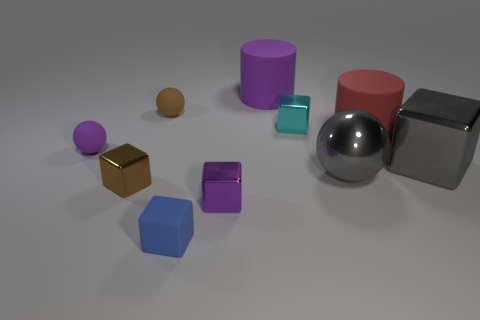Subtract all small cubes. How many cubes are left? 1 Subtract all purple cylinders. How many cylinders are left? 1 Subtract all cylinders. How many objects are left? 8 Subtract 1 cylinders. How many cylinders are left? 1 Subtract all brown cylinders. How many brown cubes are left? 1 Subtract all matte cylinders. Subtract all blue matte blocks. How many objects are left? 7 Add 5 small purple metal objects. How many small purple metal objects are left? 6 Add 2 big red cylinders. How many big red cylinders exist? 3 Subtract 0 brown cylinders. How many objects are left? 10 Subtract all cyan balls. Subtract all yellow blocks. How many balls are left? 3 